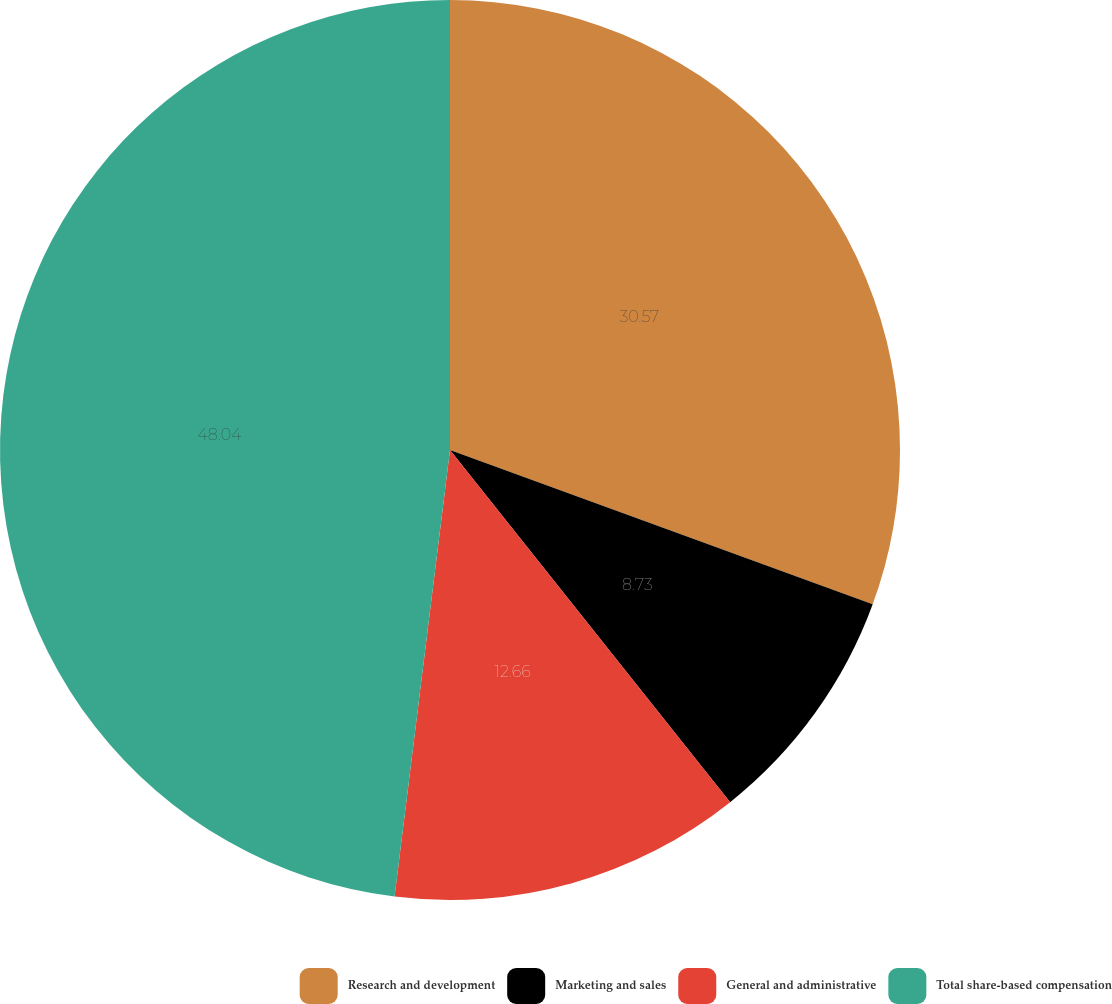<chart> <loc_0><loc_0><loc_500><loc_500><pie_chart><fcel>Research and development<fcel>Marketing and sales<fcel>General and administrative<fcel>Total share-based compensation<nl><fcel>30.57%<fcel>8.73%<fcel>12.66%<fcel>48.03%<nl></chart> 